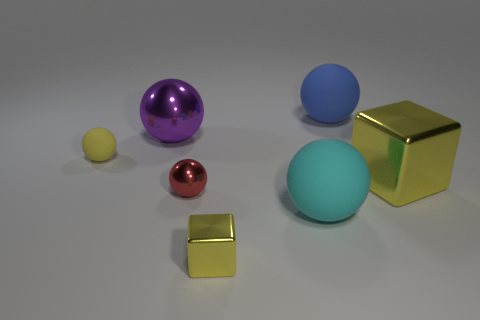Subtract all large blue rubber spheres. How many spheres are left? 4 Subtract all yellow spheres. How many spheres are left? 4 Subtract all spheres. How many objects are left? 2 Add 2 red shiny objects. How many objects exist? 9 Subtract 3 balls. How many balls are left? 2 Subtract all gray blocks. Subtract all yellow cylinders. How many blocks are left? 2 Subtract all gray cylinders. How many yellow balls are left? 1 Subtract all small blocks. Subtract all big things. How many objects are left? 2 Add 2 big yellow metallic objects. How many big yellow metallic objects are left? 3 Add 1 cyan objects. How many cyan objects exist? 2 